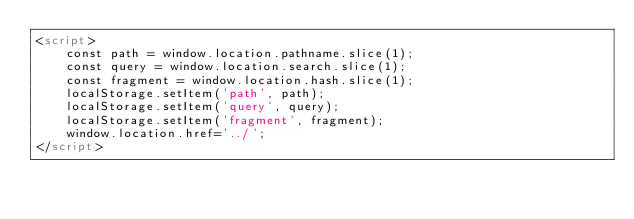<code> <loc_0><loc_0><loc_500><loc_500><_HTML_><script>
    const path = window.location.pathname.slice(1);
    const query = window.location.search.slice(1);
    const fragment = window.location.hash.slice(1);
    localStorage.setItem('path', path);
    localStorage.setItem('query', query);
    localStorage.setItem('fragment', fragment);
    window.location.href='../';
</script> </code> 